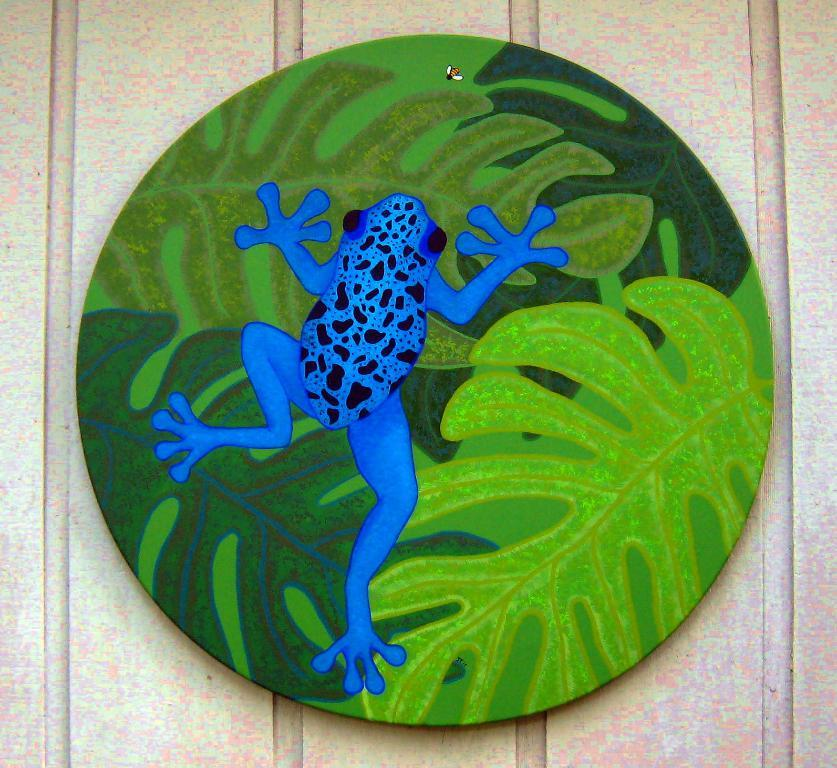What object is visible in the image? There is a coin in the image. Where is the coin located? The coin is placed on a table. What type of horse can be seen playing baseball in the image? There is no horse or baseball present in the image; it only features a coin placed on a table. 